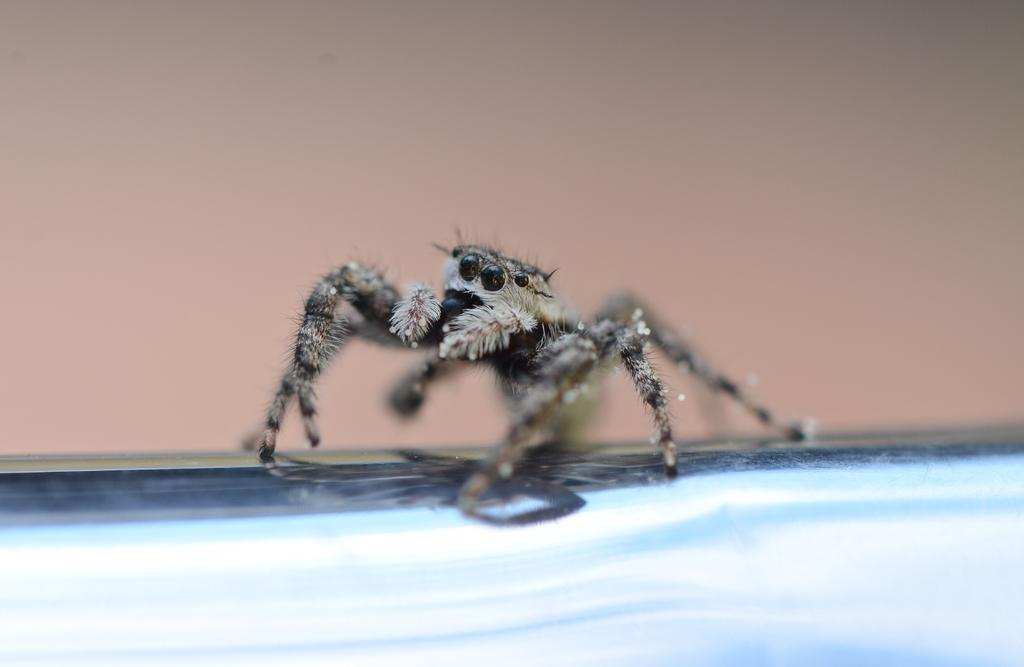What is the main subject of the picture? The main subject of the picture is a spider. Can you describe the background of the picture? The background of the picture is plain. Where is the pencil located in the picture? There is no pencil present in the image; it only features a spider and a plain background. 